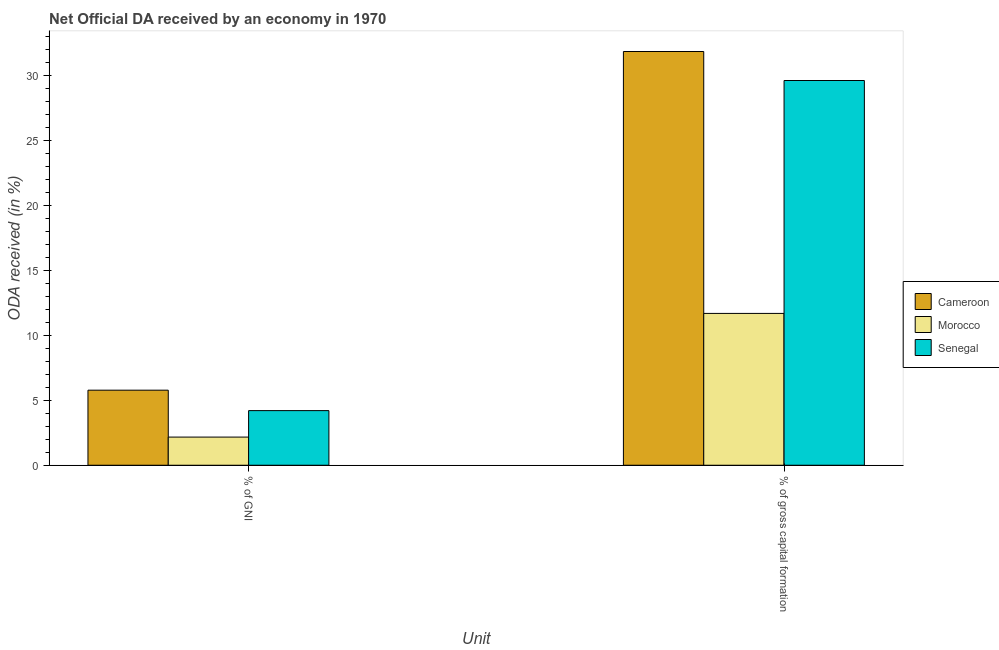How many groups of bars are there?
Your answer should be very brief. 2. How many bars are there on the 2nd tick from the left?
Provide a succinct answer. 3. How many bars are there on the 2nd tick from the right?
Make the answer very short. 3. What is the label of the 1st group of bars from the left?
Give a very brief answer. % of GNI. What is the oda received as percentage of gross capital formation in Morocco?
Your answer should be very brief. 11.7. Across all countries, what is the maximum oda received as percentage of gni?
Keep it short and to the point. 5.78. Across all countries, what is the minimum oda received as percentage of gross capital formation?
Provide a short and direct response. 11.7. In which country was the oda received as percentage of gross capital formation maximum?
Keep it short and to the point. Cameroon. In which country was the oda received as percentage of gni minimum?
Ensure brevity in your answer.  Morocco. What is the total oda received as percentage of gross capital formation in the graph?
Give a very brief answer. 73.22. What is the difference between the oda received as percentage of gross capital formation in Senegal and that in Cameroon?
Keep it short and to the point. -2.23. What is the difference between the oda received as percentage of gni in Senegal and the oda received as percentage of gross capital formation in Cameroon?
Provide a succinct answer. -27.67. What is the average oda received as percentage of gross capital formation per country?
Offer a terse response. 24.41. What is the difference between the oda received as percentage of gni and oda received as percentage of gross capital formation in Cameroon?
Provide a short and direct response. -26.1. What is the ratio of the oda received as percentage of gni in Senegal to that in Cameroon?
Keep it short and to the point. 0.73. What does the 3rd bar from the left in % of gross capital formation represents?
Make the answer very short. Senegal. What does the 1st bar from the right in % of gross capital formation represents?
Keep it short and to the point. Senegal. How many bars are there?
Your answer should be compact. 6. Are the values on the major ticks of Y-axis written in scientific E-notation?
Provide a succinct answer. No. Does the graph contain grids?
Give a very brief answer. No. Where does the legend appear in the graph?
Provide a short and direct response. Center right. How many legend labels are there?
Offer a terse response. 3. What is the title of the graph?
Your answer should be very brief. Net Official DA received by an economy in 1970. Does "Finland" appear as one of the legend labels in the graph?
Offer a terse response. No. What is the label or title of the X-axis?
Your response must be concise. Unit. What is the label or title of the Y-axis?
Your answer should be very brief. ODA received (in %). What is the ODA received (in %) of Cameroon in % of GNI?
Make the answer very short. 5.78. What is the ODA received (in %) of Morocco in % of GNI?
Provide a succinct answer. 2.17. What is the ODA received (in %) in Senegal in % of GNI?
Your response must be concise. 4.21. What is the ODA received (in %) of Cameroon in % of gross capital formation?
Your answer should be compact. 31.88. What is the ODA received (in %) of Morocco in % of gross capital formation?
Your response must be concise. 11.7. What is the ODA received (in %) in Senegal in % of gross capital formation?
Your answer should be compact. 29.64. Across all Unit, what is the maximum ODA received (in %) in Cameroon?
Your answer should be compact. 31.88. Across all Unit, what is the maximum ODA received (in %) in Morocco?
Your answer should be compact. 11.7. Across all Unit, what is the maximum ODA received (in %) in Senegal?
Provide a short and direct response. 29.64. Across all Unit, what is the minimum ODA received (in %) of Cameroon?
Your response must be concise. 5.78. Across all Unit, what is the minimum ODA received (in %) of Morocco?
Provide a short and direct response. 2.17. Across all Unit, what is the minimum ODA received (in %) in Senegal?
Offer a terse response. 4.21. What is the total ODA received (in %) of Cameroon in the graph?
Your answer should be compact. 37.66. What is the total ODA received (in %) of Morocco in the graph?
Provide a succinct answer. 13.87. What is the total ODA received (in %) of Senegal in the graph?
Offer a terse response. 33.85. What is the difference between the ODA received (in %) in Cameroon in % of GNI and that in % of gross capital formation?
Keep it short and to the point. -26.1. What is the difference between the ODA received (in %) of Morocco in % of GNI and that in % of gross capital formation?
Your answer should be compact. -9.53. What is the difference between the ODA received (in %) in Senegal in % of GNI and that in % of gross capital formation?
Provide a short and direct response. -25.43. What is the difference between the ODA received (in %) of Cameroon in % of GNI and the ODA received (in %) of Morocco in % of gross capital formation?
Ensure brevity in your answer.  -5.92. What is the difference between the ODA received (in %) of Cameroon in % of GNI and the ODA received (in %) of Senegal in % of gross capital formation?
Make the answer very short. -23.86. What is the difference between the ODA received (in %) in Morocco in % of GNI and the ODA received (in %) in Senegal in % of gross capital formation?
Give a very brief answer. -27.48. What is the average ODA received (in %) in Cameroon per Unit?
Keep it short and to the point. 18.83. What is the average ODA received (in %) in Morocco per Unit?
Your response must be concise. 6.93. What is the average ODA received (in %) of Senegal per Unit?
Ensure brevity in your answer.  16.93. What is the difference between the ODA received (in %) in Cameroon and ODA received (in %) in Morocco in % of GNI?
Your answer should be very brief. 3.61. What is the difference between the ODA received (in %) in Cameroon and ODA received (in %) in Senegal in % of GNI?
Make the answer very short. 1.57. What is the difference between the ODA received (in %) in Morocco and ODA received (in %) in Senegal in % of GNI?
Provide a short and direct response. -2.04. What is the difference between the ODA received (in %) in Cameroon and ODA received (in %) in Morocco in % of gross capital formation?
Make the answer very short. 20.18. What is the difference between the ODA received (in %) in Cameroon and ODA received (in %) in Senegal in % of gross capital formation?
Your answer should be very brief. 2.23. What is the difference between the ODA received (in %) of Morocco and ODA received (in %) of Senegal in % of gross capital formation?
Offer a terse response. -17.95. What is the ratio of the ODA received (in %) of Cameroon in % of GNI to that in % of gross capital formation?
Your response must be concise. 0.18. What is the ratio of the ODA received (in %) in Morocco in % of GNI to that in % of gross capital formation?
Your answer should be compact. 0.19. What is the ratio of the ODA received (in %) in Senegal in % of GNI to that in % of gross capital formation?
Your answer should be compact. 0.14. What is the difference between the highest and the second highest ODA received (in %) of Cameroon?
Ensure brevity in your answer.  26.1. What is the difference between the highest and the second highest ODA received (in %) of Morocco?
Provide a succinct answer. 9.53. What is the difference between the highest and the second highest ODA received (in %) of Senegal?
Provide a short and direct response. 25.43. What is the difference between the highest and the lowest ODA received (in %) of Cameroon?
Provide a succinct answer. 26.1. What is the difference between the highest and the lowest ODA received (in %) of Morocco?
Your response must be concise. 9.53. What is the difference between the highest and the lowest ODA received (in %) in Senegal?
Ensure brevity in your answer.  25.43. 